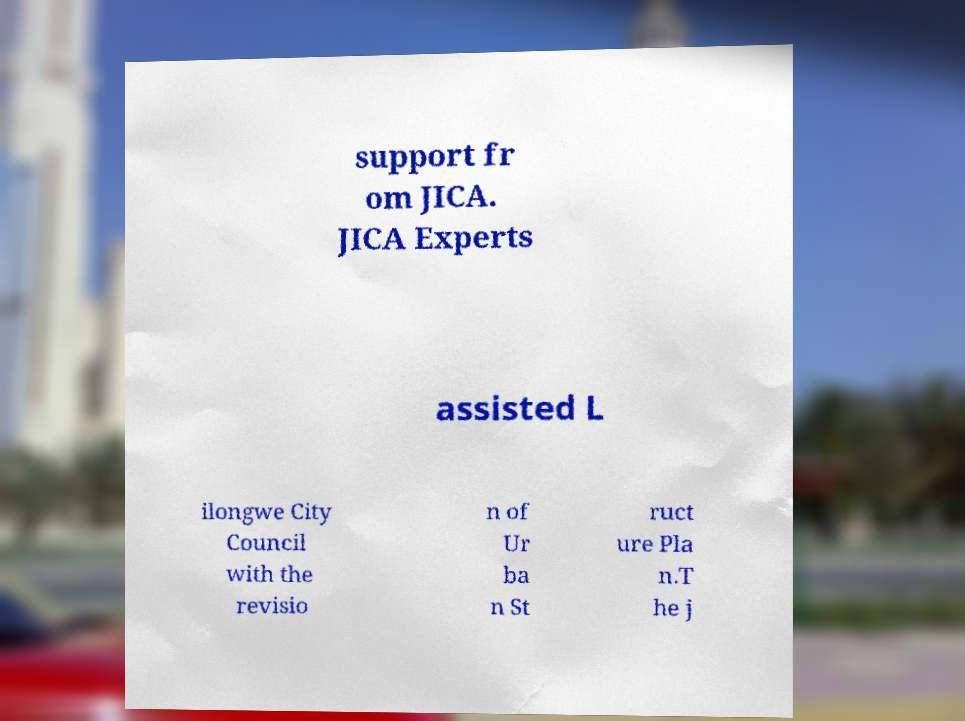For documentation purposes, I need the text within this image transcribed. Could you provide that? support fr om JICA. JICA Experts assisted L ilongwe City Council with the revisio n of Ur ba n St ruct ure Pla n.T he j 